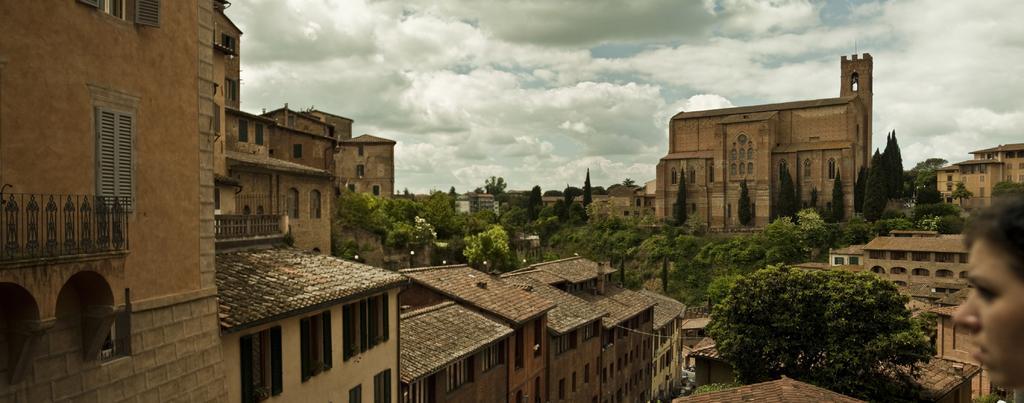How would you summarize this image in a sentence or two? In this image we can see many buildings and they are having few windows. There are many trees in the image. We can see the clouds in the sky. There are many flowers to a tree in the image. 